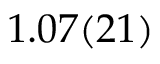<formula> <loc_0><loc_0><loc_500><loc_500>1 . 0 7 ( 2 1 )</formula> 